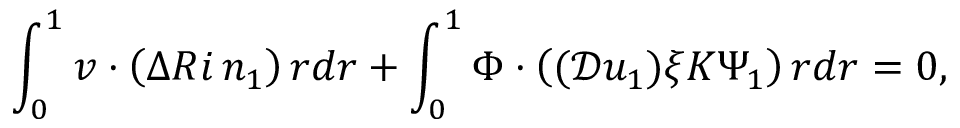<formula> <loc_0><loc_0><loc_500><loc_500>\int _ { 0 } ^ { 1 } v \cdot \left ( \Delta R i \, n _ { 1 } \right ) r d r + \int _ { 0 } ^ { 1 } \Phi \cdot \left ( ( \mathcal { D } u _ { 1 } ) \xi K \Psi _ { 1 } \right ) r d r = 0 ,</formula> 